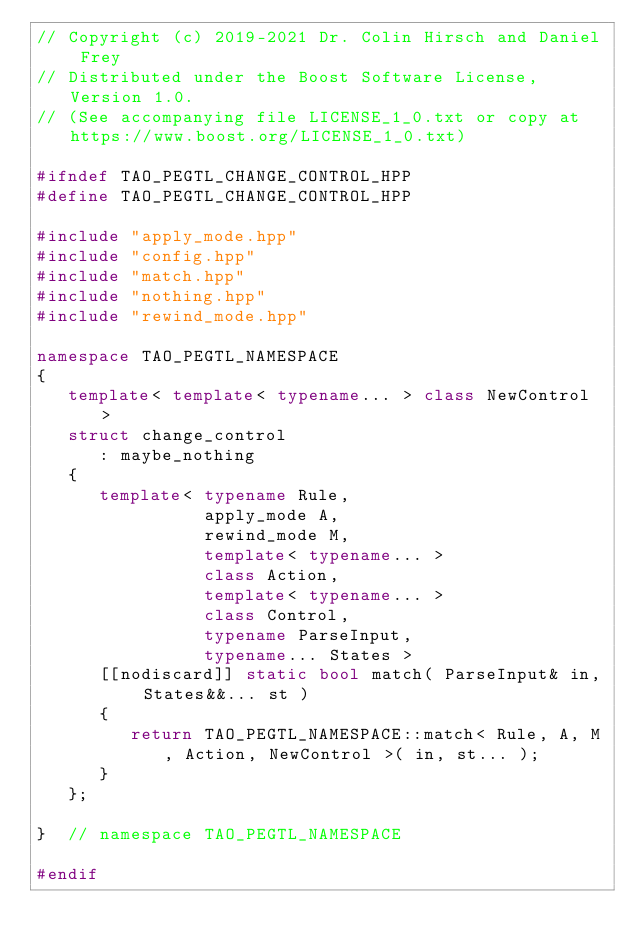<code> <loc_0><loc_0><loc_500><loc_500><_C++_>// Copyright (c) 2019-2021 Dr. Colin Hirsch and Daniel Frey
// Distributed under the Boost Software License, Version 1.0.
// (See accompanying file LICENSE_1_0.txt or copy at https://www.boost.org/LICENSE_1_0.txt)

#ifndef TAO_PEGTL_CHANGE_CONTROL_HPP
#define TAO_PEGTL_CHANGE_CONTROL_HPP

#include "apply_mode.hpp"
#include "config.hpp"
#include "match.hpp"
#include "nothing.hpp"
#include "rewind_mode.hpp"

namespace TAO_PEGTL_NAMESPACE
{
   template< template< typename... > class NewControl >
   struct change_control
      : maybe_nothing
   {
      template< typename Rule,
                apply_mode A,
                rewind_mode M,
                template< typename... >
                class Action,
                template< typename... >
                class Control,
                typename ParseInput,
                typename... States >
      [[nodiscard]] static bool match( ParseInput& in, States&&... st )
      {
         return TAO_PEGTL_NAMESPACE::match< Rule, A, M, Action, NewControl >( in, st... );
      }
   };

}  // namespace TAO_PEGTL_NAMESPACE

#endif
</code> 